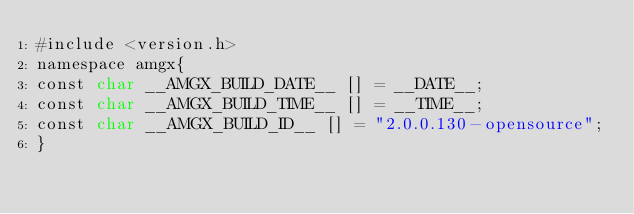Convert code to text. <code><loc_0><loc_0><loc_500><loc_500><_Cuda_>#include <version.h>
namespace amgx{
const char __AMGX_BUILD_DATE__ [] = __DATE__;
const char __AMGX_BUILD_TIME__ [] = __TIME__;
const char __AMGX_BUILD_ID__ [] = "2.0.0.130-opensource";
}
</code> 